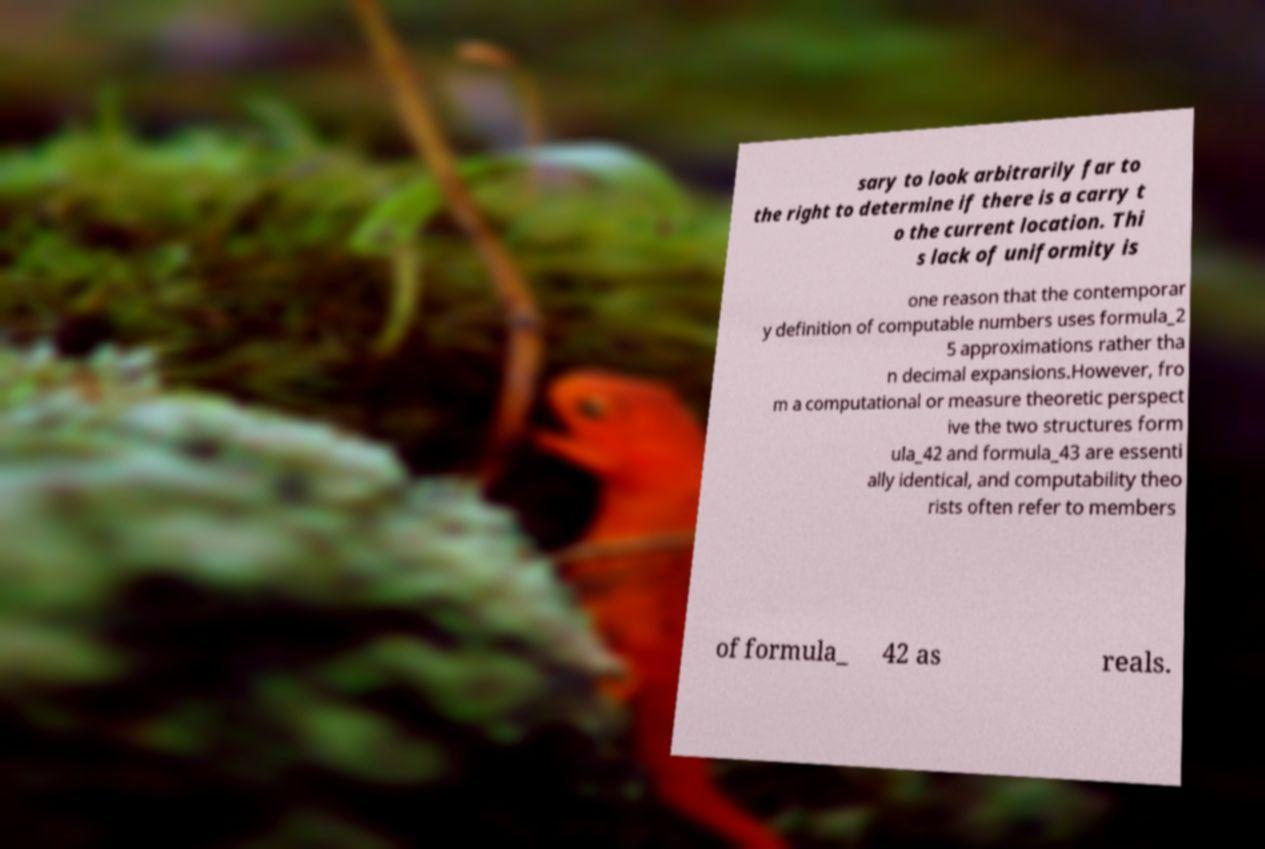What messages or text are displayed in this image? I need them in a readable, typed format. sary to look arbitrarily far to the right to determine if there is a carry t o the current location. Thi s lack of uniformity is one reason that the contemporar y definition of computable numbers uses formula_2 5 approximations rather tha n decimal expansions.However, fro m a computational or measure theoretic perspect ive the two structures form ula_42 and formula_43 are essenti ally identical, and computability theo rists often refer to members of formula_ 42 as reals. 